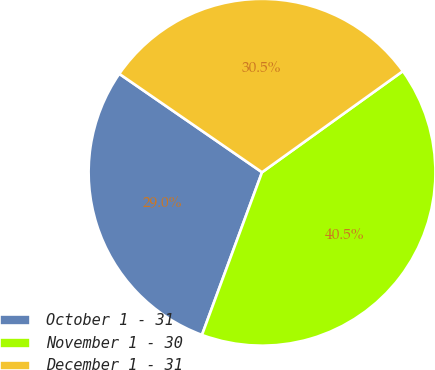<chart> <loc_0><loc_0><loc_500><loc_500><pie_chart><fcel>October 1 - 31<fcel>November 1 - 30<fcel>December 1 - 31<nl><fcel>28.98%<fcel>40.54%<fcel>30.48%<nl></chart> 